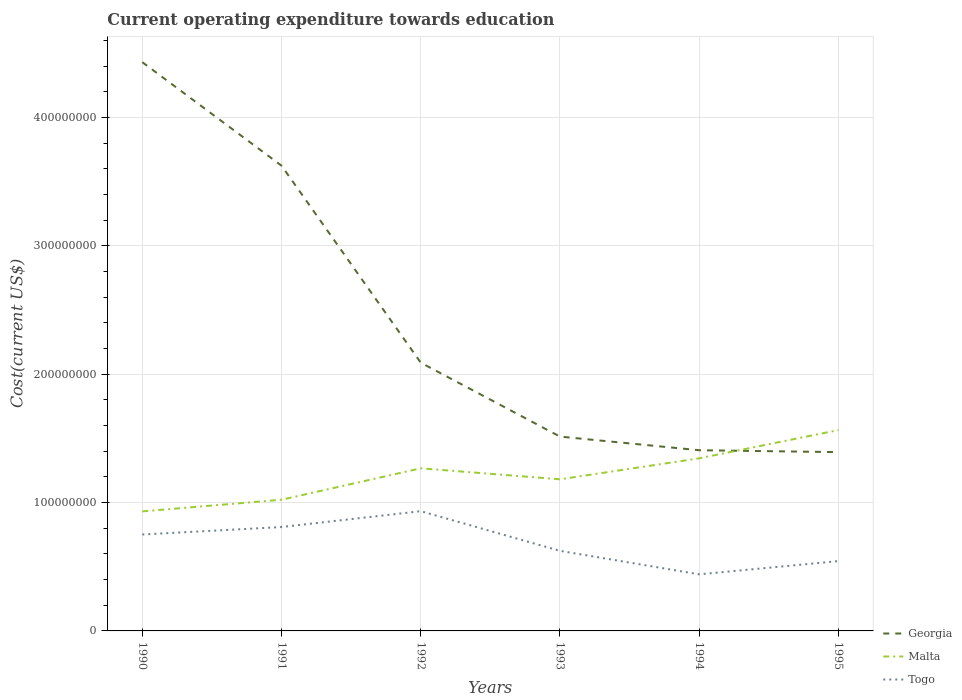Does the line corresponding to Togo intersect with the line corresponding to Georgia?
Ensure brevity in your answer.  No. Across all years, what is the maximum expenditure towards education in Malta?
Your answer should be compact. 9.31e+07. In which year was the expenditure towards education in Togo maximum?
Ensure brevity in your answer.  1994. What is the total expenditure towards education in Georgia in the graph?
Your answer should be compact. 1.53e+08. What is the difference between the highest and the second highest expenditure towards education in Togo?
Give a very brief answer. 4.92e+07. How many lines are there?
Make the answer very short. 3. Are the values on the major ticks of Y-axis written in scientific E-notation?
Provide a short and direct response. No. Does the graph contain grids?
Your response must be concise. Yes. What is the title of the graph?
Ensure brevity in your answer.  Current operating expenditure towards education. What is the label or title of the X-axis?
Make the answer very short. Years. What is the label or title of the Y-axis?
Your response must be concise. Cost(current US$). What is the Cost(current US$) in Georgia in 1990?
Your answer should be compact. 4.43e+08. What is the Cost(current US$) of Malta in 1990?
Give a very brief answer. 9.31e+07. What is the Cost(current US$) in Togo in 1990?
Your answer should be very brief. 7.51e+07. What is the Cost(current US$) of Georgia in 1991?
Offer a very short reply. 3.62e+08. What is the Cost(current US$) of Malta in 1991?
Keep it short and to the point. 1.02e+08. What is the Cost(current US$) in Togo in 1991?
Offer a terse response. 8.09e+07. What is the Cost(current US$) in Georgia in 1992?
Ensure brevity in your answer.  2.09e+08. What is the Cost(current US$) of Malta in 1992?
Provide a succinct answer. 1.27e+08. What is the Cost(current US$) in Togo in 1992?
Give a very brief answer. 9.33e+07. What is the Cost(current US$) in Georgia in 1993?
Provide a short and direct response. 1.51e+08. What is the Cost(current US$) of Malta in 1993?
Give a very brief answer. 1.18e+08. What is the Cost(current US$) of Togo in 1993?
Provide a succinct answer. 6.24e+07. What is the Cost(current US$) in Georgia in 1994?
Give a very brief answer. 1.41e+08. What is the Cost(current US$) of Malta in 1994?
Provide a succinct answer. 1.34e+08. What is the Cost(current US$) in Togo in 1994?
Provide a succinct answer. 4.41e+07. What is the Cost(current US$) in Georgia in 1995?
Ensure brevity in your answer.  1.39e+08. What is the Cost(current US$) in Malta in 1995?
Give a very brief answer. 1.56e+08. What is the Cost(current US$) in Togo in 1995?
Offer a terse response. 5.44e+07. Across all years, what is the maximum Cost(current US$) in Georgia?
Offer a very short reply. 4.43e+08. Across all years, what is the maximum Cost(current US$) of Malta?
Offer a terse response. 1.56e+08. Across all years, what is the maximum Cost(current US$) in Togo?
Make the answer very short. 9.33e+07. Across all years, what is the minimum Cost(current US$) of Georgia?
Keep it short and to the point. 1.39e+08. Across all years, what is the minimum Cost(current US$) in Malta?
Provide a short and direct response. 9.31e+07. Across all years, what is the minimum Cost(current US$) of Togo?
Ensure brevity in your answer.  4.41e+07. What is the total Cost(current US$) in Georgia in the graph?
Make the answer very short. 1.45e+09. What is the total Cost(current US$) of Malta in the graph?
Offer a terse response. 7.31e+08. What is the total Cost(current US$) in Togo in the graph?
Your response must be concise. 4.10e+08. What is the difference between the Cost(current US$) of Georgia in 1990 and that in 1991?
Ensure brevity in your answer.  8.06e+07. What is the difference between the Cost(current US$) in Malta in 1990 and that in 1991?
Keep it short and to the point. -9.09e+06. What is the difference between the Cost(current US$) in Togo in 1990 and that in 1991?
Provide a short and direct response. -5.83e+06. What is the difference between the Cost(current US$) of Georgia in 1990 and that in 1992?
Make the answer very short. 2.34e+08. What is the difference between the Cost(current US$) in Malta in 1990 and that in 1992?
Provide a short and direct response. -3.36e+07. What is the difference between the Cost(current US$) in Togo in 1990 and that in 1992?
Provide a succinct answer. -1.82e+07. What is the difference between the Cost(current US$) in Georgia in 1990 and that in 1993?
Offer a very short reply. 2.92e+08. What is the difference between the Cost(current US$) of Malta in 1990 and that in 1993?
Offer a very short reply. -2.50e+07. What is the difference between the Cost(current US$) in Togo in 1990 and that in 1993?
Make the answer very short. 1.27e+07. What is the difference between the Cost(current US$) of Georgia in 1990 and that in 1994?
Your answer should be very brief. 3.02e+08. What is the difference between the Cost(current US$) of Malta in 1990 and that in 1994?
Your response must be concise. -4.13e+07. What is the difference between the Cost(current US$) in Togo in 1990 and that in 1994?
Make the answer very short. 3.10e+07. What is the difference between the Cost(current US$) in Georgia in 1990 and that in 1995?
Offer a very short reply. 3.04e+08. What is the difference between the Cost(current US$) in Malta in 1990 and that in 1995?
Give a very brief answer. -6.33e+07. What is the difference between the Cost(current US$) in Togo in 1990 and that in 1995?
Offer a very short reply. 2.07e+07. What is the difference between the Cost(current US$) of Georgia in 1991 and that in 1992?
Ensure brevity in your answer.  1.53e+08. What is the difference between the Cost(current US$) in Malta in 1991 and that in 1992?
Your response must be concise. -2.45e+07. What is the difference between the Cost(current US$) of Togo in 1991 and that in 1992?
Your answer should be very brief. -1.23e+07. What is the difference between the Cost(current US$) of Georgia in 1991 and that in 1993?
Make the answer very short. 2.11e+08. What is the difference between the Cost(current US$) in Malta in 1991 and that in 1993?
Give a very brief answer. -1.59e+07. What is the difference between the Cost(current US$) in Togo in 1991 and that in 1993?
Ensure brevity in your answer.  1.86e+07. What is the difference between the Cost(current US$) in Georgia in 1991 and that in 1994?
Offer a terse response. 2.22e+08. What is the difference between the Cost(current US$) in Malta in 1991 and that in 1994?
Keep it short and to the point. -3.22e+07. What is the difference between the Cost(current US$) of Togo in 1991 and that in 1994?
Offer a very short reply. 3.69e+07. What is the difference between the Cost(current US$) of Georgia in 1991 and that in 1995?
Your response must be concise. 2.23e+08. What is the difference between the Cost(current US$) of Malta in 1991 and that in 1995?
Your response must be concise. -5.43e+07. What is the difference between the Cost(current US$) in Togo in 1991 and that in 1995?
Give a very brief answer. 2.65e+07. What is the difference between the Cost(current US$) of Georgia in 1992 and that in 1993?
Provide a short and direct response. 5.76e+07. What is the difference between the Cost(current US$) in Malta in 1992 and that in 1993?
Your answer should be very brief. 8.56e+06. What is the difference between the Cost(current US$) in Togo in 1992 and that in 1993?
Offer a terse response. 3.09e+07. What is the difference between the Cost(current US$) in Georgia in 1992 and that in 1994?
Your response must be concise. 6.82e+07. What is the difference between the Cost(current US$) in Malta in 1992 and that in 1994?
Your response must be concise. -7.78e+06. What is the difference between the Cost(current US$) in Togo in 1992 and that in 1994?
Keep it short and to the point. 4.92e+07. What is the difference between the Cost(current US$) in Georgia in 1992 and that in 1995?
Your answer should be compact. 6.97e+07. What is the difference between the Cost(current US$) in Malta in 1992 and that in 1995?
Provide a succinct answer. -2.98e+07. What is the difference between the Cost(current US$) in Togo in 1992 and that in 1995?
Your answer should be compact. 3.89e+07. What is the difference between the Cost(current US$) of Georgia in 1993 and that in 1994?
Provide a succinct answer. 1.06e+07. What is the difference between the Cost(current US$) in Malta in 1993 and that in 1994?
Ensure brevity in your answer.  -1.63e+07. What is the difference between the Cost(current US$) in Togo in 1993 and that in 1994?
Give a very brief answer. 1.83e+07. What is the difference between the Cost(current US$) of Georgia in 1993 and that in 1995?
Make the answer very short. 1.21e+07. What is the difference between the Cost(current US$) of Malta in 1993 and that in 1995?
Provide a succinct answer. -3.83e+07. What is the difference between the Cost(current US$) of Togo in 1993 and that in 1995?
Your answer should be compact. 7.98e+06. What is the difference between the Cost(current US$) of Georgia in 1994 and that in 1995?
Ensure brevity in your answer.  1.48e+06. What is the difference between the Cost(current US$) of Malta in 1994 and that in 1995?
Keep it short and to the point. -2.20e+07. What is the difference between the Cost(current US$) of Togo in 1994 and that in 1995?
Provide a short and direct response. -1.03e+07. What is the difference between the Cost(current US$) in Georgia in 1990 and the Cost(current US$) in Malta in 1991?
Provide a succinct answer. 3.41e+08. What is the difference between the Cost(current US$) of Georgia in 1990 and the Cost(current US$) of Togo in 1991?
Provide a succinct answer. 3.62e+08. What is the difference between the Cost(current US$) of Malta in 1990 and the Cost(current US$) of Togo in 1991?
Your answer should be very brief. 1.22e+07. What is the difference between the Cost(current US$) in Georgia in 1990 and the Cost(current US$) in Malta in 1992?
Provide a succinct answer. 3.16e+08. What is the difference between the Cost(current US$) in Georgia in 1990 and the Cost(current US$) in Togo in 1992?
Offer a very short reply. 3.50e+08. What is the difference between the Cost(current US$) of Malta in 1990 and the Cost(current US$) of Togo in 1992?
Give a very brief answer. -1.58e+05. What is the difference between the Cost(current US$) in Georgia in 1990 and the Cost(current US$) in Malta in 1993?
Ensure brevity in your answer.  3.25e+08. What is the difference between the Cost(current US$) in Georgia in 1990 and the Cost(current US$) in Togo in 1993?
Your answer should be very brief. 3.81e+08. What is the difference between the Cost(current US$) of Malta in 1990 and the Cost(current US$) of Togo in 1993?
Give a very brief answer. 3.07e+07. What is the difference between the Cost(current US$) of Georgia in 1990 and the Cost(current US$) of Malta in 1994?
Give a very brief answer. 3.09e+08. What is the difference between the Cost(current US$) of Georgia in 1990 and the Cost(current US$) of Togo in 1994?
Provide a succinct answer. 3.99e+08. What is the difference between the Cost(current US$) of Malta in 1990 and the Cost(current US$) of Togo in 1994?
Ensure brevity in your answer.  4.90e+07. What is the difference between the Cost(current US$) in Georgia in 1990 and the Cost(current US$) in Malta in 1995?
Make the answer very short. 2.87e+08. What is the difference between the Cost(current US$) in Georgia in 1990 and the Cost(current US$) in Togo in 1995?
Provide a succinct answer. 3.89e+08. What is the difference between the Cost(current US$) of Malta in 1990 and the Cost(current US$) of Togo in 1995?
Ensure brevity in your answer.  3.87e+07. What is the difference between the Cost(current US$) of Georgia in 1991 and the Cost(current US$) of Malta in 1992?
Keep it short and to the point. 2.36e+08. What is the difference between the Cost(current US$) of Georgia in 1991 and the Cost(current US$) of Togo in 1992?
Provide a succinct answer. 2.69e+08. What is the difference between the Cost(current US$) of Malta in 1991 and the Cost(current US$) of Togo in 1992?
Your answer should be very brief. 8.93e+06. What is the difference between the Cost(current US$) in Georgia in 1991 and the Cost(current US$) in Malta in 1993?
Your answer should be very brief. 2.44e+08. What is the difference between the Cost(current US$) in Georgia in 1991 and the Cost(current US$) in Togo in 1993?
Provide a short and direct response. 3.00e+08. What is the difference between the Cost(current US$) in Malta in 1991 and the Cost(current US$) in Togo in 1993?
Make the answer very short. 3.98e+07. What is the difference between the Cost(current US$) of Georgia in 1991 and the Cost(current US$) of Malta in 1994?
Give a very brief answer. 2.28e+08. What is the difference between the Cost(current US$) in Georgia in 1991 and the Cost(current US$) in Togo in 1994?
Your answer should be very brief. 3.18e+08. What is the difference between the Cost(current US$) in Malta in 1991 and the Cost(current US$) in Togo in 1994?
Give a very brief answer. 5.81e+07. What is the difference between the Cost(current US$) in Georgia in 1991 and the Cost(current US$) in Malta in 1995?
Keep it short and to the point. 2.06e+08. What is the difference between the Cost(current US$) in Georgia in 1991 and the Cost(current US$) in Togo in 1995?
Provide a succinct answer. 3.08e+08. What is the difference between the Cost(current US$) of Malta in 1991 and the Cost(current US$) of Togo in 1995?
Your answer should be very brief. 4.78e+07. What is the difference between the Cost(current US$) in Georgia in 1992 and the Cost(current US$) in Malta in 1993?
Your response must be concise. 9.08e+07. What is the difference between the Cost(current US$) of Georgia in 1992 and the Cost(current US$) of Togo in 1993?
Provide a succinct answer. 1.47e+08. What is the difference between the Cost(current US$) in Malta in 1992 and the Cost(current US$) in Togo in 1993?
Your answer should be compact. 6.43e+07. What is the difference between the Cost(current US$) of Georgia in 1992 and the Cost(current US$) of Malta in 1994?
Ensure brevity in your answer.  7.45e+07. What is the difference between the Cost(current US$) of Georgia in 1992 and the Cost(current US$) of Togo in 1994?
Make the answer very short. 1.65e+08. What is the difference between the Cost(current US$) of Malta in 1992 and the Cost(current US$) of Togo in 1994?
Offer a terse response. 8.26e+07. What is the difference between the Cost(current US$) of Georgia in 1992 and the Cost(current US$) of Malta in 1995?
Offer a terse response. 5.25e+07. What is the difference between the Cost(current US$) in Georgia in 1992 and the Cost(current US$) in Togo in 1995?
Your response must be concise. 1.55e+08. What is the difference between the Cost(current US$) in Malta in 1992 and the Cost(current US$) in Togo in 1995?
Provide a succinct answer. 7.23e+07. What is the difference between the Cost(current US$) of Georgia in 1993 and the Cost(current US$) of Malta in 1994?
Provide a short and direct response. 1.69e+07. What is the difference between the Cost(current US$) in Georgia in 1993 and the Cost(current US$) in Togo in 1994?
Keep it short and to the point. 1.07e+08. What is the difference between the Cost(current US$) of Malta in 1993 and the Cost(current US$) of Togo in 1994?
Offer a terse response. 7.40e+07. What is the difference between the Cost(current US$) of Georgia in 1993 and the Cost(current US$) of Malta in 1995?
Offer a terse response. -5.08e+06. What is the difference between the Cost(current US$) of Georgia in 1993 and the Cost(current US$) of Togo in 1995?
Offer a terse response. 9.70e+07. What is the difference between the Cost(current US$) of Malta in 1993 and the Cost(current US$) of Togo in 1995?
Offer a very short reply. 6.37e+07. What is the difference between the Cost(current US$) in Georgia in 1994 and the Cost(current US$) in Malta in 1995?
Keep it short and to the point. -1.57e+07. What is the difference between the Cost(current US$) of Georgia in 1994 and the Cost(current US$) of Togo in 1995?
Provide a short and direct response. 8.64e+07. What is the difference between the Cost(current US$) in Malta in 1994 and the Cost(current US$) in Togo in 1995?
Offer a very short reply. 8.00e+07. What is the average Cost(current US$) of Georgia per year?
Ensure brevity in your answer.  2.41e+08. What is the average Cost(current US$) of Malta per year?
Keep it short and to the point. 1.22e+08. What is the average Cost(current US$) in Togo per year?
Your response must be concise. 6.84e+07. In the year 1990, what is the difference between the Cost(current US$) in Georgia and Cost(current US$) in Malta?
Your answer should be very brief. 3.50e+08. In the year 1990, what is the difference between the Cost(current US$) in Georgia and Cost(current US$) in Togo?
Offer a very short reply. 3.68e+08. In the year 1990, what is the difference between the Cost(current US$) of Malta and Cost(current US$) of Togo?
Provide a succinct answer. 1.80e+07. In the year 1991, what is the difference between the Cost(current US$) in Georgia and Cost(current US$) in Malta?
Provide a succinct answer. 2.60e+08. In the year 1991, what is the difference between the Cost(current US$) of Georgia and Cost(current US$) of Togo?
Ensure brevity in your answer.  2.81e+08. In the year 1991, what is the difference between the Cost(current US$) in Malta and Cost(current US$) in Togo?
Offer a very short reply. 2.13e+07. In the year 1992, what is the difference between the Cost(current US$) in Georgia and Cost(current US$) in Malta?
Ensure brevity in your answer.  8.23e+07. In the year 1992, what is the difference between the Cost(current US$) in Georgia and Cost(current US$) in Togo?
Keep it short and to the point. 1.16e+08. In the year 1992, what is the difference between the Cost(current US$) of Malta and Cost(current US$) of Togo?
Give a very brief answer. 3.34e+07. In the year 1993, what is the difference between the Cost(current US$) of Georgia and Cost(current US$) of Malta?
Make the answer very short. 3.33e+07. In the year 1993, what is the difference between the Cost(current US$) of Georgia and Cost(current US$) of Togo?
Offer a terse response. 8.90e+07. In the year 1993, what is the difference between the Cost(current US$) in Malta and Cost(current US$) in Togo?
Offer a very short reply. 5.57e+07. In the year 1994, what is the difference between the Cost(current US$) of Georgia and Cost(current US$) of Malta?
Offer a terse response. 6.31e+06. In the year 1994, what is the difference between the Cost(current US$) of Georgia and Cost(current US$) of Togo?
Provide a short and direct response. 9.67e+07. In the year 1994, what is the difference between the Cost(current US$) of Malta and Cost(current US$) of Togo?
Your response must be concise. 9.04e+07. In the year 1995, what is the difference between the Cost(current US$) of Georgia and Cost(current US$) of Malta?
Provide a short and direct response. -1.72e+07. In the year 1995, what is the difference between the Cost(current US$) of Georgia and Cost(current US$) of Togo?
Keep it short and to the point. 8.49e+07. In the year 1995, what is the difference between the Cost(current US$) in Malta and Cost(current US$) in Togo?
Provide a short and direct response. 1.02e+08. What is the ratio of the Cost(current US$) of Georgia in 1990 to that in 1991?
Your answer should be compact. 1.22. What is the ratio of the Cost(current US$) in Malta in 1990 to that in 1991?
Your answer should be very brief. 0.91. What is the ratio of the Cost(current US$) in Togo in 1990 to that in 1991?
Your answer should be very brief. 0.93. What is the ratio of the Cost(current US$) in Georgia in 1990 to that in 1992?
Give a very brief answer. 2.12. What is the ratio of the Cost(current US$) of Malta in 1990 to that in 1992?
Make the answer very short. 0.74. What is the ratio of the Cost(current US$) in Togo in 1990 to that in 1992?
Your answer should be very brief. 0.81. What is the ratio of the Cost(current US$) in Georgia in 1990 to that in 1993?
Your response must be concise. 2.93. What is the ratio of the Cost(current US$) in Malta in 1990 to that in 1993?
Provide a succinct answer. 0.79. What is the ratio of the Cost(current US$) of Togo in 1990 to that in 1993?
Offer a very short reply. 1.2. What is the ratio of the Cost(current US$) of Georgia in 1990 to that in 1994?
Keep it short and to the point. 3.15. What is the ratio of the Cost(current US$) in Malta in 1990 to that in 1994?
Make the answer very short. 0.69. What is the ratio of the Cost(current US$) of Togo in 1990 to that in 1994?
Offer a terse response. 1.7. What is the ratio of the Cost(current US$) of Georgia in 1990 to that in 1995?
Give a very brief answer. 3.18. What is the ratio of the Cost(current US$) in Malta in 1990 to that in 1995?
Offer a terse response. 0.6. What is the ratio of the Cost(current US$) in Togo in 1990 to that in 1995?
Ensure brevity in your answer.  1.38. What is the ratio of the Cost(current US$) of Georgia in 1991 to that in 1992?
Provide a short and direct response. 1.73. What is the ratio of the Cost(current US$) of Malta in 1991 to that in 1992?
Give a very brief answer. 0.81. What is the ratio of the Cost(current US$) of Togo in 1991 to that in 1992?
Provide a succinct answer. 0.87. What is the ratio of the Cost(current US$) in Georgia in 1991 to that in 1993?
Your answer should be compact. 2.39. What is the ratio of the Cost(current US$) of Malta in 1991 to that in 1993?
Your answer should be compact. 0.87. What is the ratio of the Cost(current US$) in Togo in 1991 to that in 1993?
Ensure brevity in your answer.  1.3. What is the ratio of the Cost(current US$) in Georgia in 1991 to that in 1994?
Your answer should be compact. 2.57. What is the ratio of the Cost(current US$) of Malta in 1991 to that in 1994?
Provide a short and direct response. 0.76. What is the ratio of the Cost(current US$) of Togo in 1991 to that in 1994?
Give a very brief answer. 1.84. What is the ratio of the Cost(current US$) of Georgia in 1991 to that in 1995?
Provide a succinct answer. 2.6. What is the ratio of the Cost(current US$) in Malta in 1991 to that in 1995?
Your answer should be very brief. 0.65. What is the ratio of the Cost(current US$) in Togo in 1991 to that in 1995?
Your answer should be compact. 1.49. What is the ratio of the Cost(current US$) in Georgia in 1992 to that in 1993?
Offer a very short reply. 1.38. What is the ratio of the Cost(current US$) in Malta in 1992 to that in 1993?
Your answer should be compact. 1.07. What is the ratio of the Cost(current US$) of Togo in 1992 to that in 1993?
Your answer should be very brief. 1.5. What is the ratio of the Cost(current US$) in Georgia in 1992 to that in 1994?
Your answer should be very brief. 1.48. What is the ratio of the Cost(current US$) in Malta in 1992 to that in 1994?
Your answer should be compact. 0.94. What is the ratio of the Cost(current US$) in Togo in 1992 to that in 1994?
Offer a terse response. 2.12. What is the ratio of the Cost(current US$) in Georgia in 1992 to that in 1995?
Provide a succinct answer. 1.5. What is the ratio of the Cost(current US$) in Malta in 1992 to that in 1995?
Make the answer very short. 0.81. What is the ratio of the Cost(current US$) in Togo in 1992 to that in 1995?
Keep it short and to the point. 1.71. What is the ratio of the Cost(current US$) in Georgia in 1993 to that in 1994?
Offer a very short reply. 1.08. What is the ratio of the Cost(current US$) of Malta in 1993 to that in 1994?
Provide a short and direct response. 0.88. What is the ratio of the Cost(current US$) of Togo in 1993 to that in 1994?
Your answer should be compact. 1.42. What is the ratio of the Cost(current US$) in Georgia in 1993 to that in 1995?
Provide a succinct answer. 1.09. What is the ratio of the Cost(current US$) in Malta in 1993 to that in 1995?
Your response must be concise. 0.75. What is the ratio of the Cost(current US$) in Togo in 1993 to that in 1995?
Your answer should be compact. 1.15. What is the ratio of the Cost(current US$) in Georgia in 1994 to that in 1995?
Provide a short and direct response. 1.01. What is the ratio of the Cost(current US$) of Malta in 1994 to that in 1995?
Offer a very short reply. 0.86. What is the ratio of the Cost(current US$) of Togo in 1994 to that in 1995?
Give a very brief answer. 0.81. What is the difference between the highest and the second highest Cost(current US$) of Georgia?
Offer a terse response. 8.06e+07. What is the difference between the highest and the second highest Cost(current US$) of Malta?
Keep it short and to the point. 2.20e+07. What is the difference between the highest and the second highest Cost(current US$) in Togo?
Keep it short and to the point. 1.23e+07. What is the difference between the highest and the lowest Cost(current US$) of Georgia?
Make the answer very short. 3.04e+08. What is the difference between the highest and the lowest Cost(current US$) in Malta?
Offer a very short reply. 6.33e+07. What is the difference between the highest and the lowest Cost(current US$) in Togo?
Give a very brief answer. 4.92e+07. 